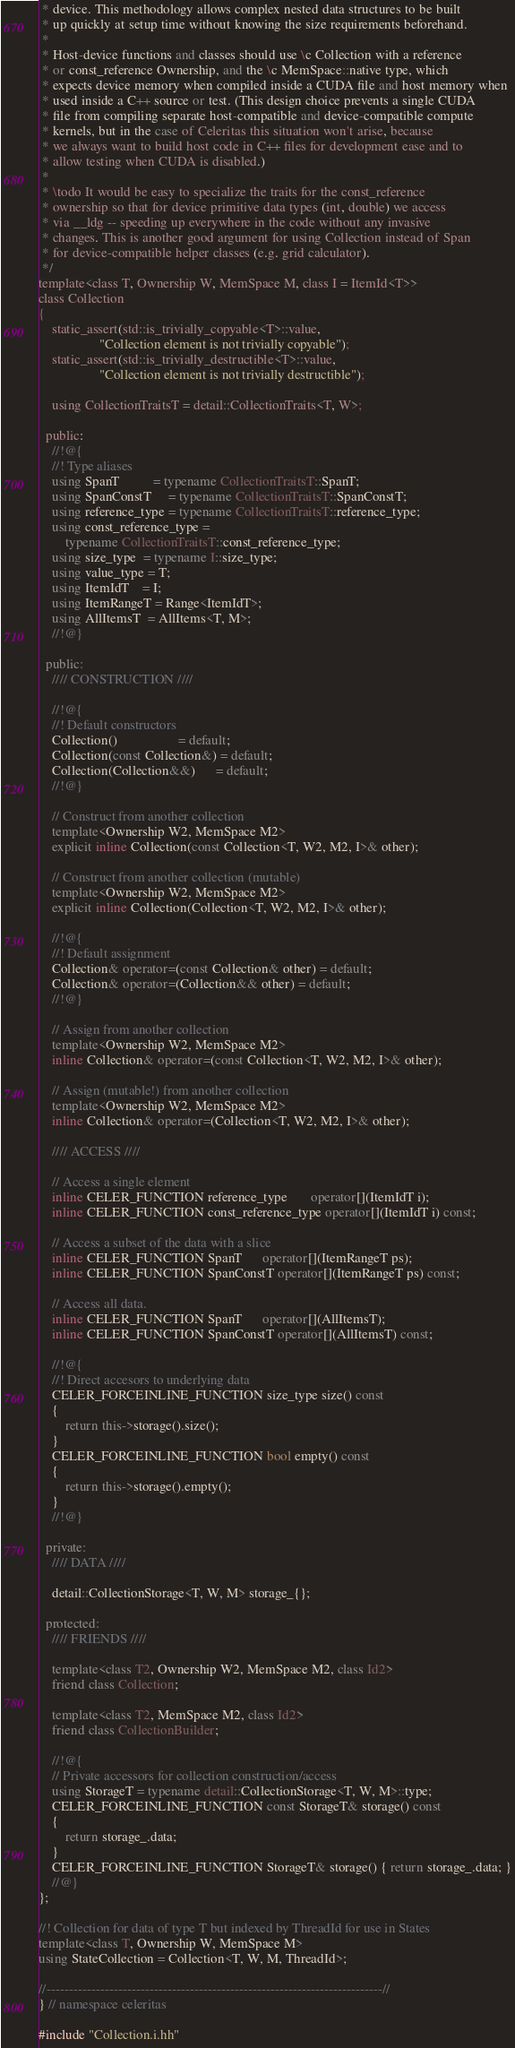<code> <loc_0><loc_0><loc_500><loc_500><_C++_> * device. This methodology allows complex nested data structures to be built
 * up quickly at setup time without knowing the size requirements beforehand.
 *
 * Host-device functions and classes should use \c Collection with a reference
 * or const_reference Ownership, and the \c MemSpace::native type, which
 * expects device memory when compiled inside a CUDA file and host memory when
 * used inside a C++ source or test. (This design choice prevents a single CUDA
 * file from compiling separate host-compatible and device-compatible compute
 * kernels, but in the case of Celeritas this situation won't arise, because
 * we always want to build host code in C++ files for development ease and to
 * allow testing when CUDA is disabled.)
 *
 * \todo It would be easy to specialize the traits for the const_reference
 * ownership so that for device primitive data types (int, double) we access
 * via __ldg -- speeding up everywhere in the code without any invasive
 * changes. This is another good argument for using Collection instead of Span
 * for device-compatible helper classes (e.g. grid calculator).
 */
template<class T, Ownership W, MemSpace M, class I = ItemId<T>>
class Collection
{
    static_assert(std::is_trivially_copyable<T>::value,
                  "Collection element is not trivially copyable");
    static_assert(std::is_trivially_destructible<T>::value,
                  "Collection element is not trivially destructible");

    using CollectionTraitsT = detail::CollectionTraits<T, W>;

  public:
    //!@{
    //! Type aliases
    using SpanT          = typename CollectionTraitsT::SpanT;
    using SpanConstT     = typename CollectionTraitsT::SpanConstT;
    using reference_type = typename CollectionTraitsT::reference_type;
    using const_reference_type =
        typename CollectionTraitsT::const_reference_type;
    using size_type  = typename I::size_type;
    using value_type = T;
    using ItemIdT    = I;
    using ItemRangeT = Range<ItemIdT>;
    using AllItemsT  = AllItems<T, M>;
    //!@}

  public:
    //// CONSTRUCTION ////

    //!@{
    //! Default constructors
    Collection()                  = default;
    Collection(const Collection&) = default;
    Collection(Collection&&)      = default;
    //!@}

    // Construct from another collection
    template<Ownership W2, MemSpace M2>
    explicit inline Collection(const Collection<T, W2, M2, I>& other);

    // Construct from another collection (mutable)
    template<Ownership W2, MemSpace M2>
    explicit inline Collection(Collection<T, W2, M2, I>& other);

    //!@{
    //! Default assignment
    Collection& operator=(const Collection& other) = default;
    Collection& operator=(Collection&& other) = default;
    //!@}

    // Assign from another collection
    template<Ownership W2, MemSpace M2>
    inline Collection& operator=(const Collection<T, W2, M2, I>& other);

    // Assign (mutable!) from another collection
    template<Ownership W2, MemSpace M2>
    inline Collection& operator=(Collection<T, W2, M2, I>& other);

    //// ACCESS ////

    // Access a single element
    inline CELER_FUNCTION reference_type       operator[](ItemIdT i);
    inline CELER_FUNCTION const_reference_type operator[](ItemIdT i) const;

    // Access a subset of the data with a slice
    inline CELER_FUNCTION SpanT      operator[](ItemRangeT ps);
    inline CELER_FUNCTION SpanConstT operator[](ItemRangeT ps) const;

    // Access all data.
    inline CELER_FUNCTION SpanT      operator[](AllItemsT);
    inline CELER_FUNCTION SpanConstT operator[](AllItemsT) const;

    //!@{
    //! Direct accesors to underlying data
    CELER_FORCEINLINE_FUNCTION size_type size() const
    {
        return this->storage().size();
    }
    CELER_FORCEINLINE_FUNCTION bool empty() const
    {
        return this->storage().empty();
    }
    //!@}

  private:
    //// DATA ////

    detail::CollectionStorage<T, W, M> storage_{};

  protected:
    //// FRIENDS ////

    template<class T2, Ownership W2, MemSpace M2, class Id2>
    friend class Collection;

    template<class T2, MemSpace M2, class Id2>
    friend class CollectionBuilder;

    //!@{
    // Private accessors for collection construction/access
    using StorageT = typename detail::CollectionStorage<T, W, M>::type;
    CELER_FORCEINLINE_FUNCTION const StorageT& storage() const
    {
        return storage_.data;
    }
    CELER_FORCEINLINE_FUNCTION StorageT& storage() { return storage_.data; }
    //@}
};

//! Collection for data of type T but indexed by ThreadId for use in States
template<class T, Ownership W, MemSpace M>
using StateCollection = Collection<T, W, M, ThreadId>;

//---------------------------------------------------------------------------//
} // namespace celeritas

#include "Collection.i.hh"
</code> 